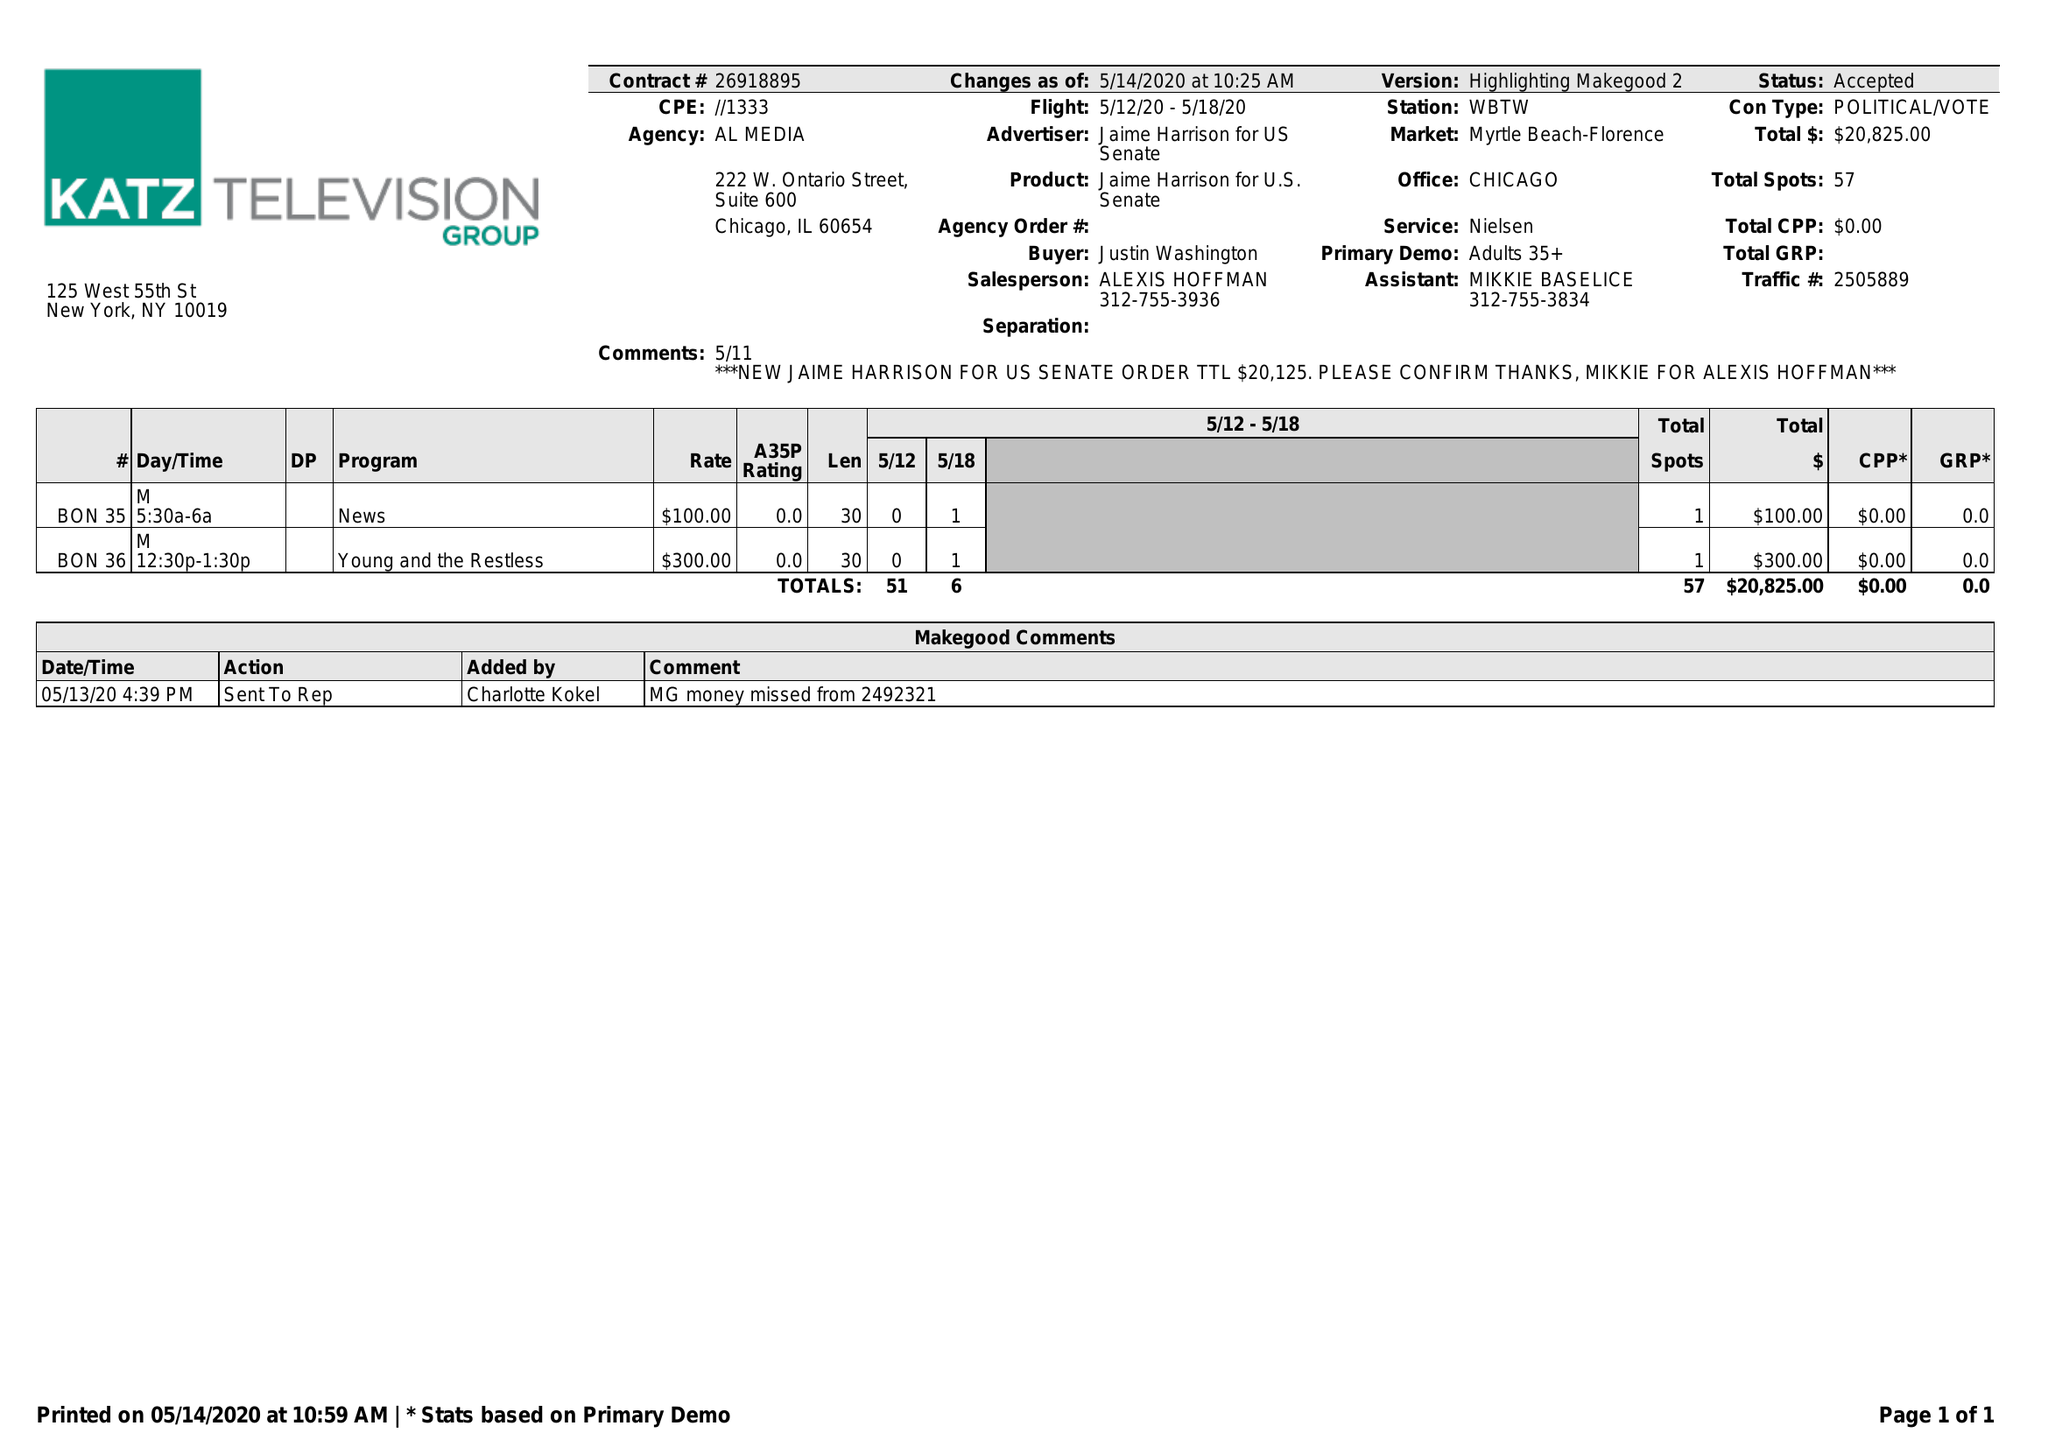What is the value for the gross_amount?
Answer the question using a single word or phrase. 20825.00 